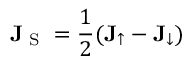Convert formula to latex. <formula><loc_0><loc_0><loc_500><loc_500>J _ { S } = \frac { 1 } { 2 } ( J _ { \uparrow } - J _ { \downarrow } )</formula> 